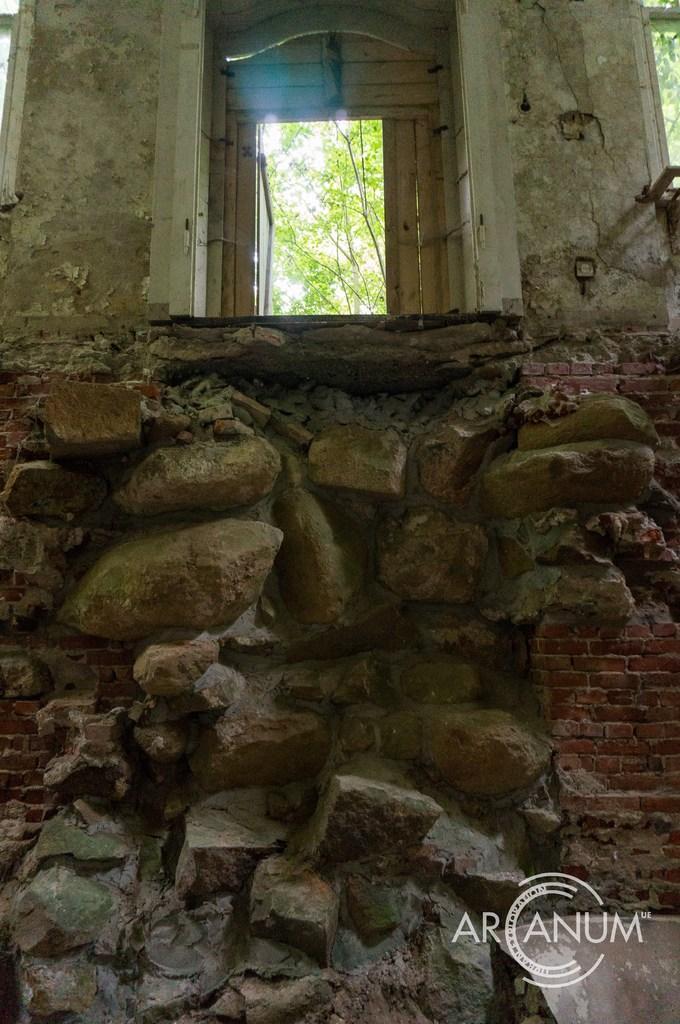Please provide a concise description of this image. In this image I can see a wall and a window. In the outside I can see a tree. 